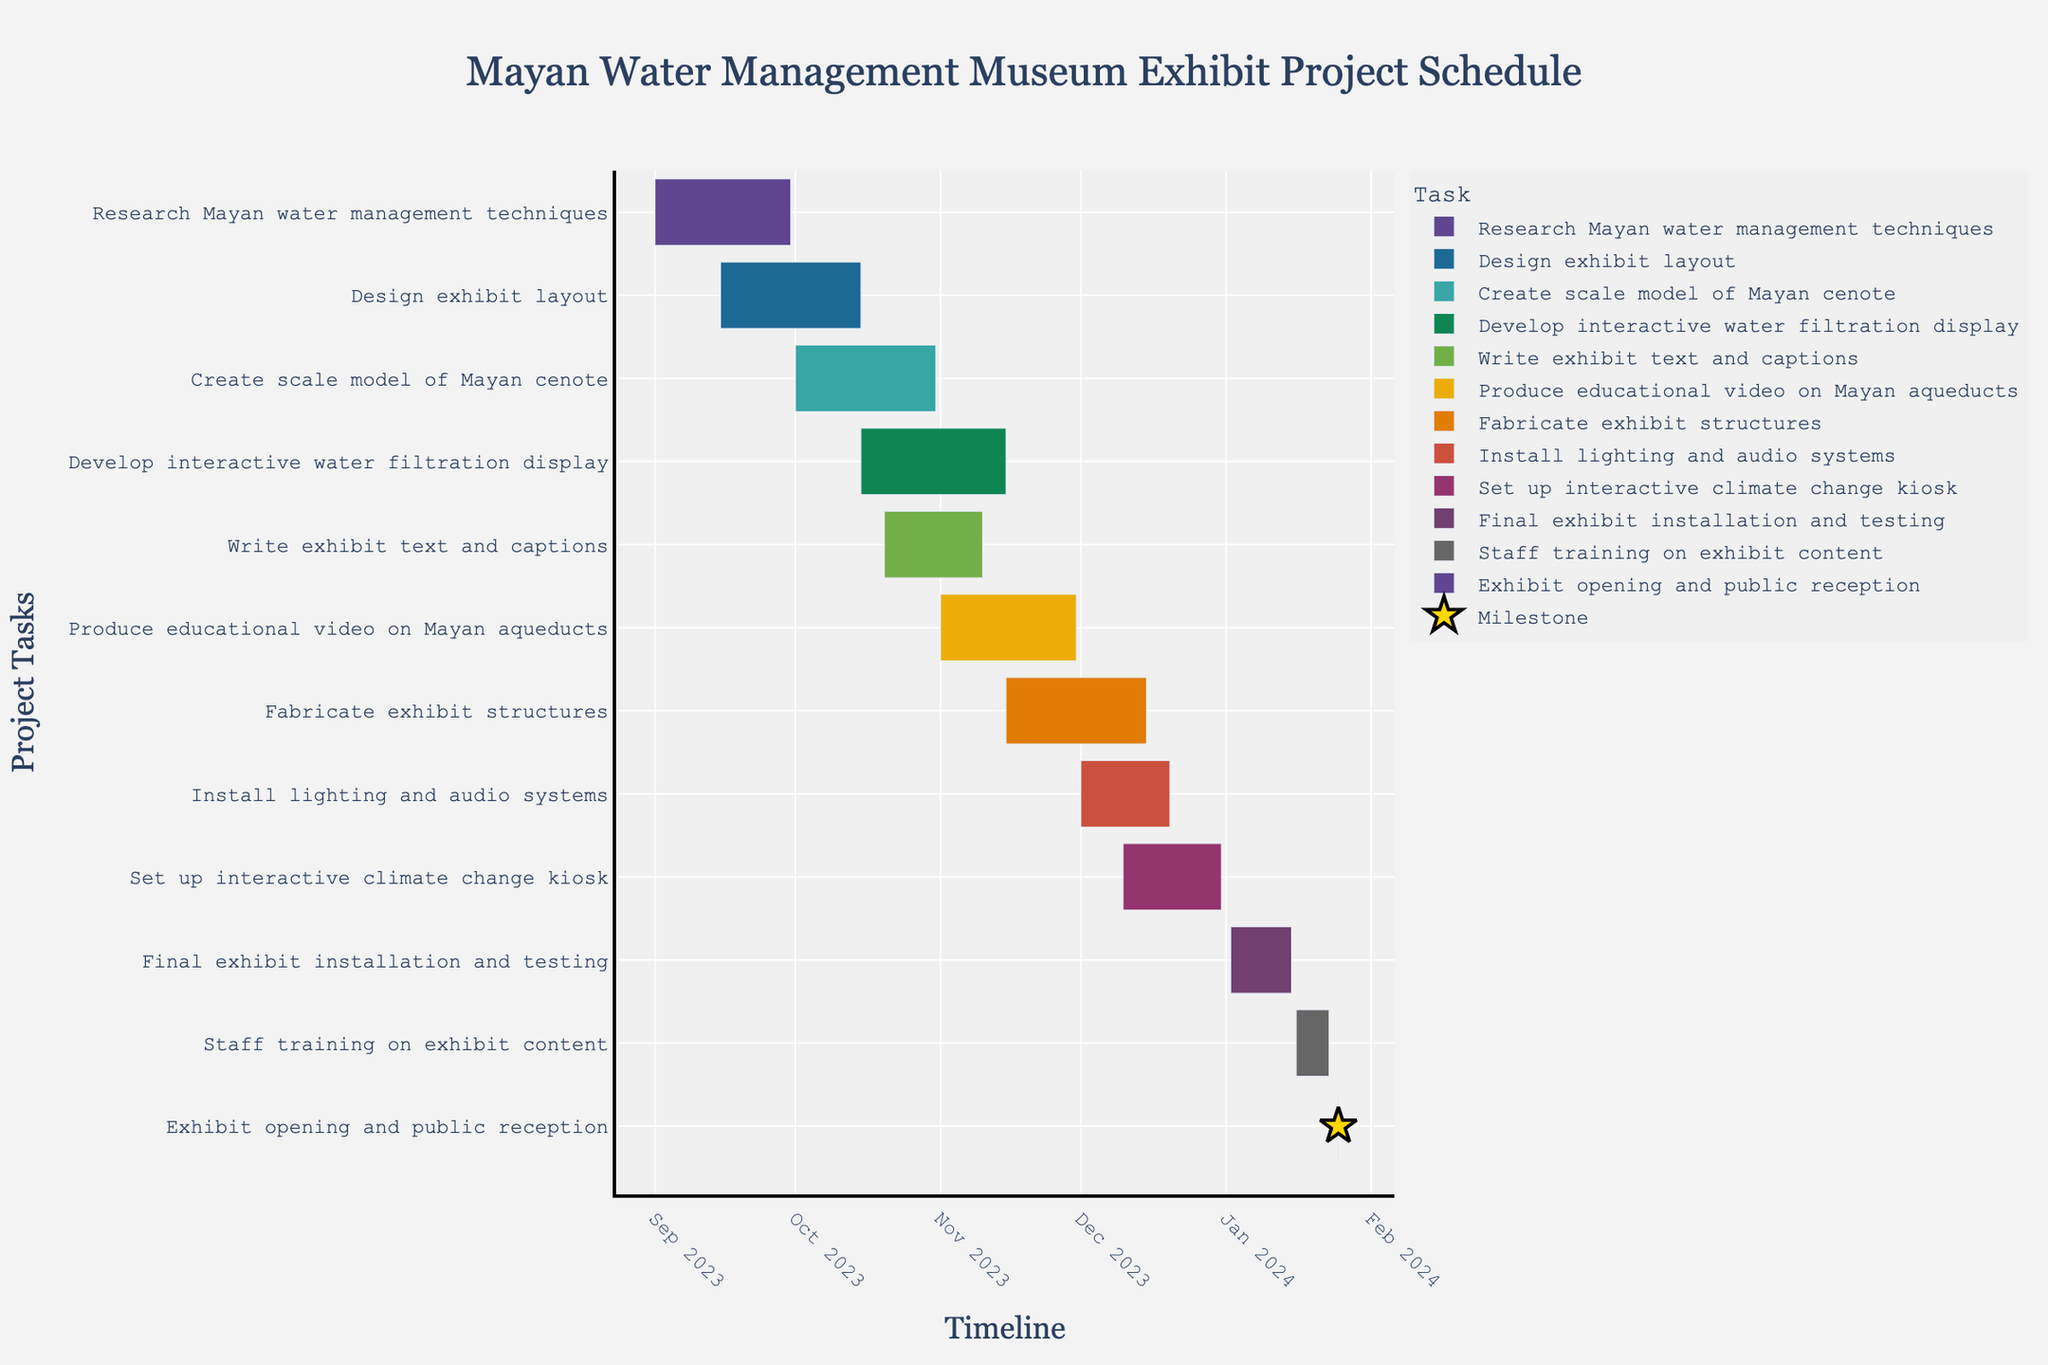What is the title of the Gantt chart? The title of a chart is usually placed at the top of the figure and summarizes the content represented. In this case, it would summarize the overall purpose or focus of the Gantt chart.
Answer: Mayan Water Management Museum Exhibit Project Schedule How many tasks are displayed in the Gantt chart? To determine the number of tasks, count the distinct task labels listed along the y-axis.
Answer: 11 Which task starts first and when does it start? By examining the x-axis and the start dates of each task, the earliest starting date indicates the first task.
Answer: Research Mayan water management techniques, 2023-09-01 Which task takes the longest to complete and what is its duration? Compare the duration values of all tasks. The longest duration task will have the highest number of days specified.
Answer: Develop interactive water filtration display, 32 days How many tasks overlap during the month of October 2023? Identify the tasks with start and end dates that fall within October 2023. Count these tasks.
Answer: Four tasks Which tasks are milestones and how are they visually represented? Tasks with a duration of 1 day and marked differently (often with special symbols like stars), as indicated in the description.
Answer: Exhibit opening and public reception, represented by star markers When does the "Fabricate exhibit structures" task start and end? Check the row corresponding to "Fabricate exhibit structures" to identify the start and end dates on the x-axis.
Answer: Starts on 2023-11-15 and ends on 2023-12-15 What is the total duration for completing the "Install lighting and audio systems" and "Set up interactive climate change kiosk" tasks combined? Add the durations of "Install lighting and audio systems" (20 days) and "Set up interactive climate change kiosk" (22 days).
Answer: 42 days Which tasks need to be completed before "Install lighting and audio systems" can begin? Identify tasks that end before the start date of "Install lighting and audio systems" (2023-12-01). These tasks must logically precede it.
Answer: Produce educational video on Mayan aqueducts and Fabricate exhibit structures How many tasks are scheduled to occur during December 2023? Identify tasks that have durations overlapping with December 2023 by checking their start and end dates. Count these tasks.
Answer: Four tasks 